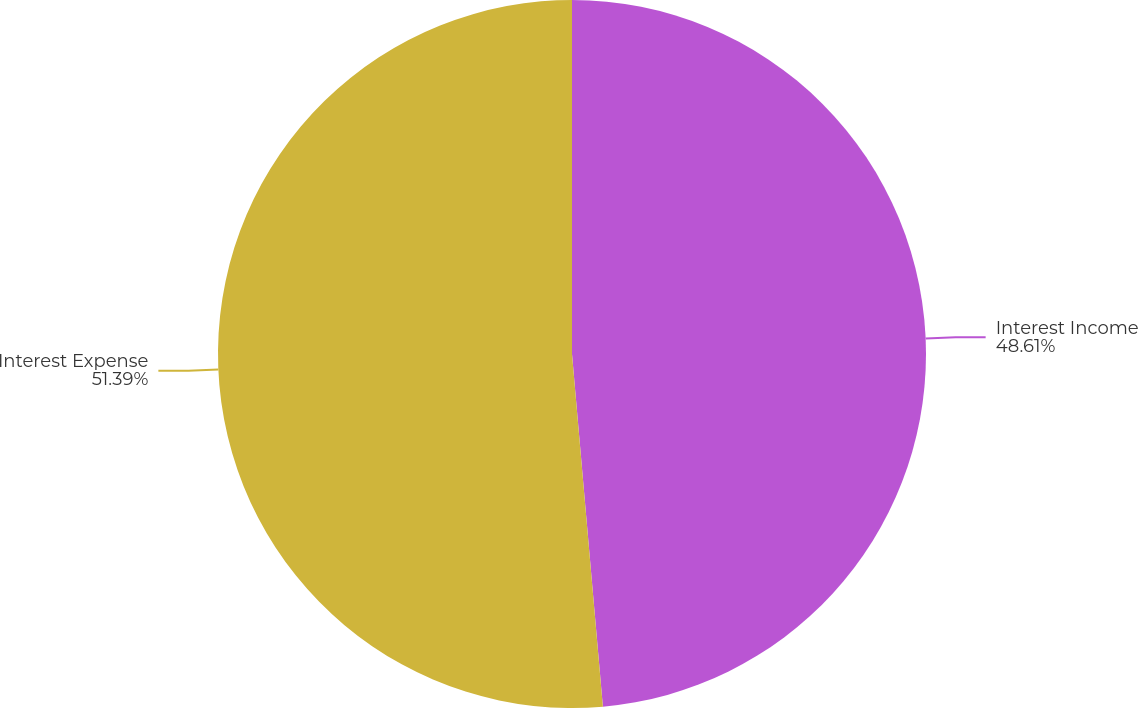Convert chart. <chart><loc_0><loc_0><loc_500><loc_500><pie_chart><fcel>Interest Income<fcel>Interest Expense<nl><fcel>48.61%<fcel>51.39%<nl></chart> 